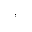Convert formula to latex. <formula><loc_0><loc_0><loc_500><loc_500>^ { , }</formula> 